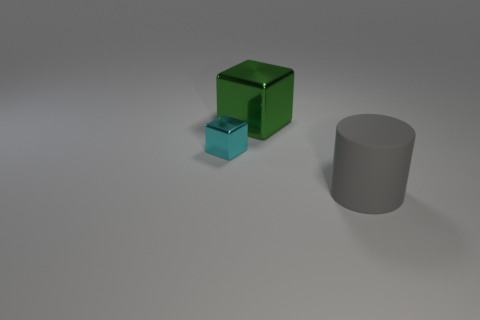What number of other cyan things have the same material as the cyan object?
Provide a succinct answer. 0. Is the number of shiny objects less than the number of big gray matte cylinders?
Offer a terse response. No. There is a metal object that is to the left of the large thing behind the rubber thing; what number of gray things are to the left of it?
Make the answer very short. 0. What number of large matte things are in front of the large green thing?
Provide a short and direct response. 1. There is another big object that is the same shape as the cyan metal object; what color is it?
Make the answer very short. Green. What material is the thing that is in front of the green shiny object and behind the gray object?
Make the answer very short. Metal. Does the metal thing that is behind the cyan thing have the same size as the small block?
Your response must be concise. No. What material is the green cube?
Give a very brief answer. Metal. The large thing in front of the small metallic thing is what color?
Offer a very short reply. Gray. What number of small things are either green metal objects or cyan shiny cubes?
Your answer should be compact. 1. 